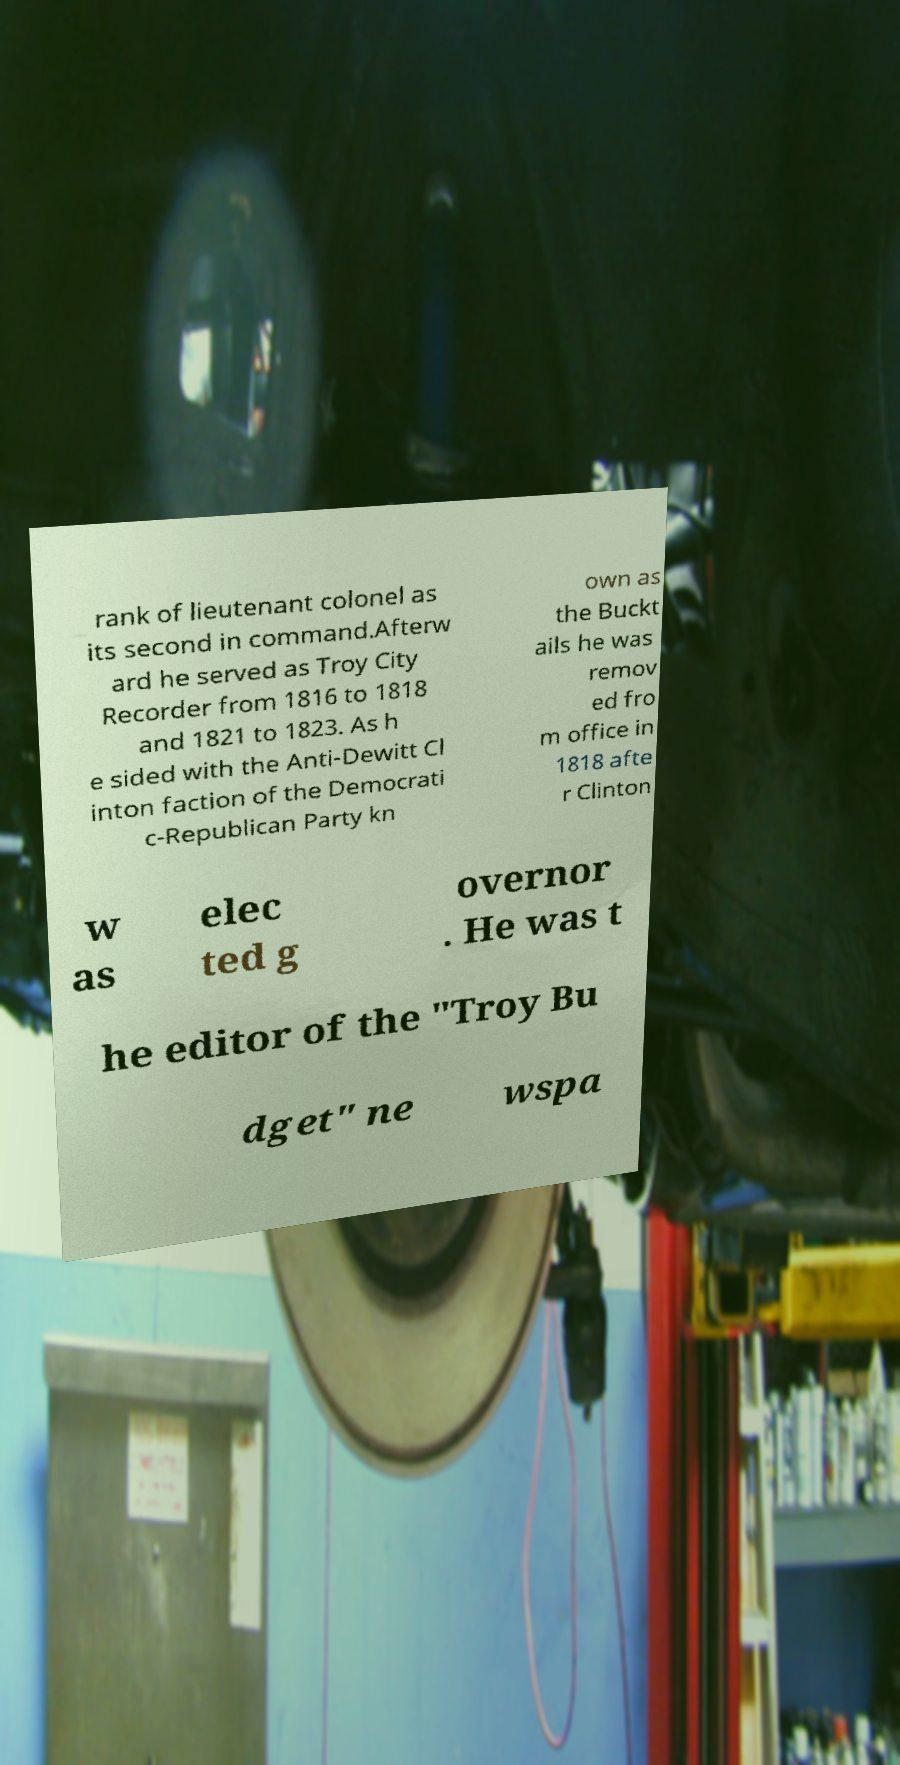There's text embedded in this image that I need extracted. Can you transcribe it verbatim? rank of lieutenant colonel as its second in command.Afterw ard he served as Troy City Recorder from 1816 to 1818 and 1821 to 1823. As h e sided with the Anti-Dewitt Cl inton faction of the Democrati c-Republican Party kn own as the Buckt ails he was remov ed fro m office in 1818 afte r Clinton w as elec ted g overnor . He was t he editor of the "Troy Bu dget" ne wspa 